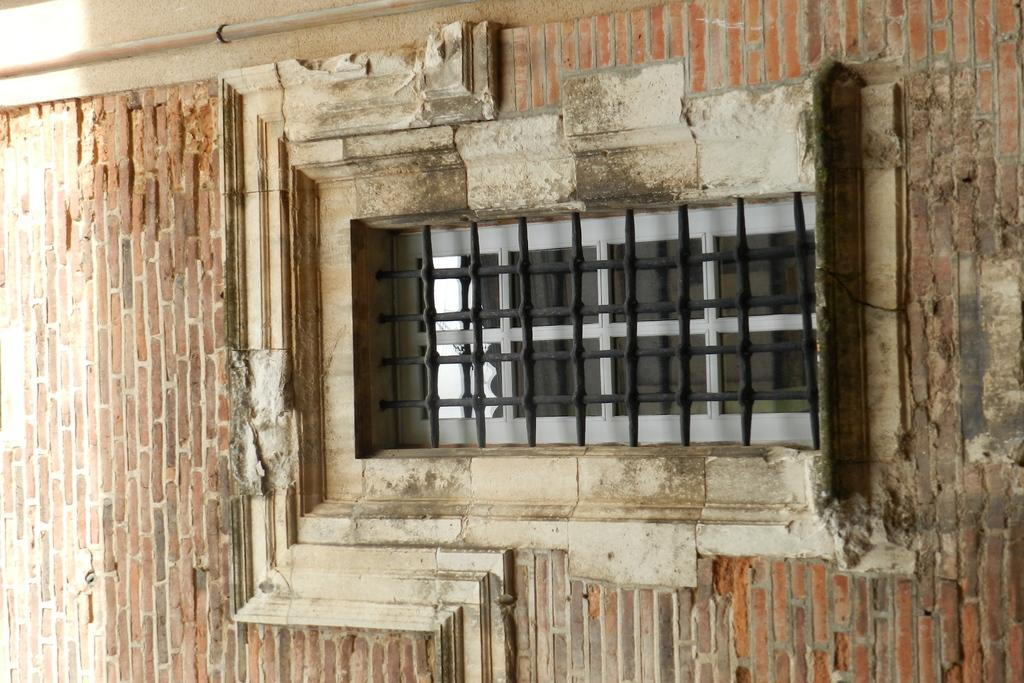What is the possible location from where the image was taken? The image might be taken from outside of a building. What can be seen in the middle of the image? There is a grill window in the middle of the image. What type of wall is visible in the background of the image? There is a brick wall in the background of the image. What else can be seen in the background of the image? Pipes are visible in the background of the image. What type of memory is being stored in the pipes in the image? There is no indication in the image that the pipes are storing any type of memory; they are likely part of the building's infrastructure. 